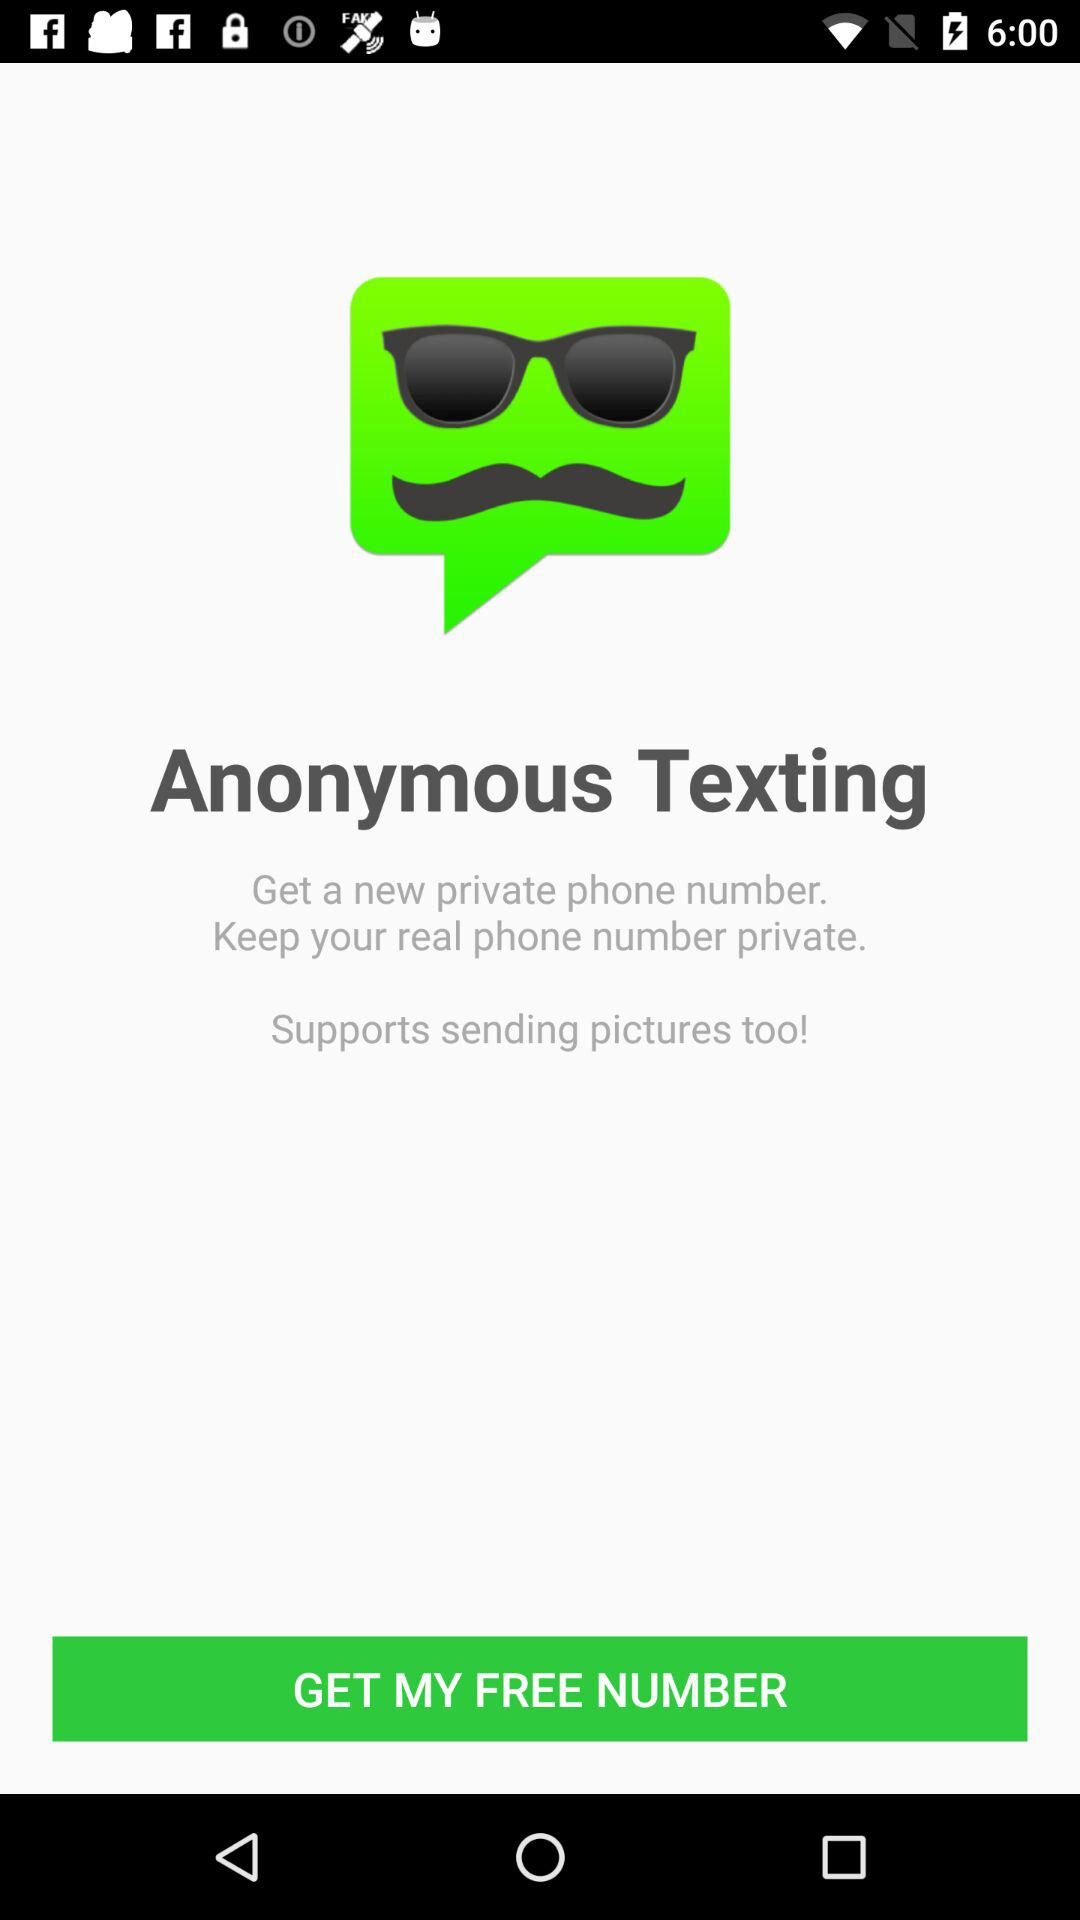What is the application name? The application name is "Anonymous Texting". 